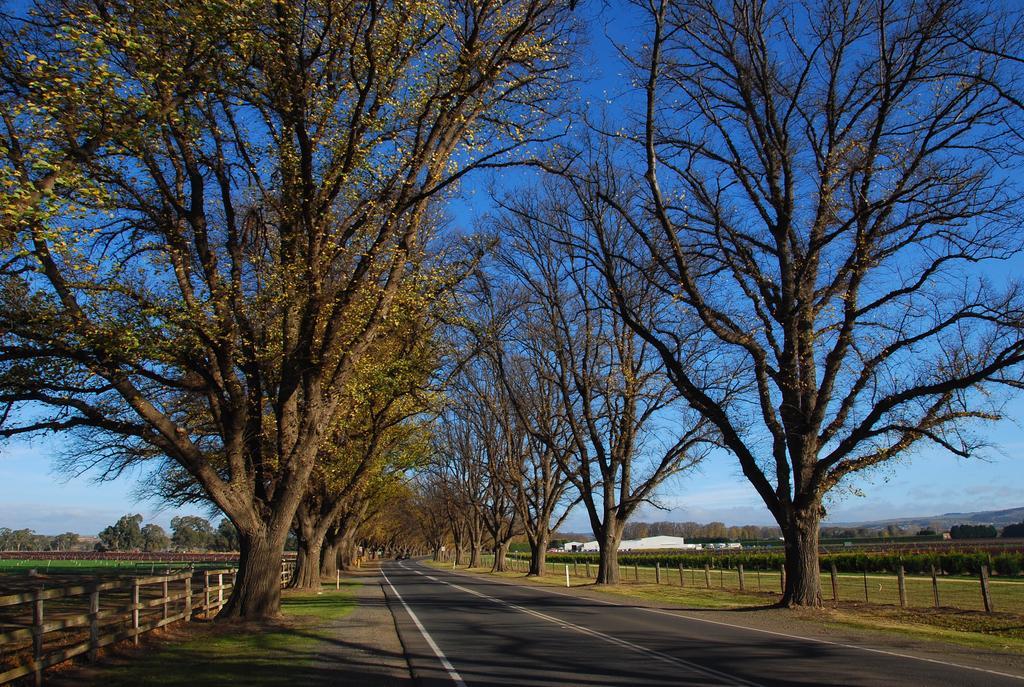How would you summarize this image in a sentence or two? In this image there is a road at the center and on both right and left side of the image there are trees. At the background there are buildings and on both right and left side of the image fencing is done and at the top there is Sky. 